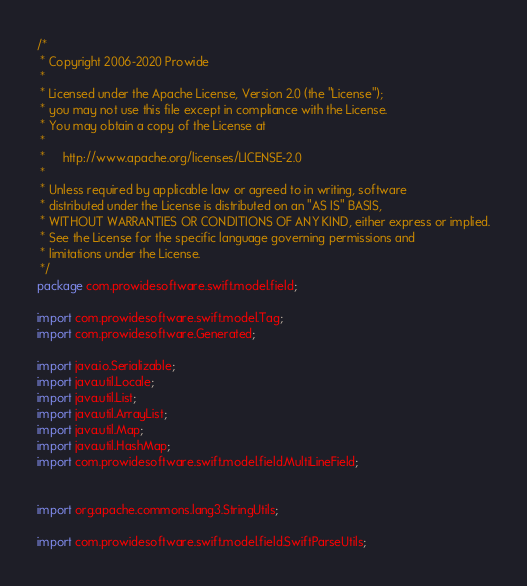<code> <loc_0><loc_0><loc_500><loc_500><_Java_>/*
 * Copyright 2006-2020 Prowide
 *
 * Licensed under the Apache License, Version 2.0 (the "License");
 * you may not use this file except in compliance with the License.
 * You may obtain a copy of the License at
 *
 *     http://www.apache.org/licenses/LICENSE-2.0
 *
 * Unless required by applicable law or agreed to in writing, software
 * distributed under the License is distributed on an "AS IS" BASIS,
 * WITHOUT WARRANTIES OR CONDITIONS OF ANY KIND, either express or implied.
 * See the License for the specific language governing permissions and
 * limitations under the License.
 */
package com.prowidesoftware.swift.model.field;

import com.prowidesoftware.swift.model.Tag;
import com.prowidesoftware.Generated;

import java.io.Serializable;
import java.util.Locale;
import java.util.List;
import java.util.ArrayList;
import java.util.Map;
import java.util.HashMap;
import com.prowidesoftware.swift.model.field.MultiLineField;


import org.apache.commons.lang3.StringUtils;

import com.prowidesoftware.swift.model.field.SwiftParseUtils;</code> 